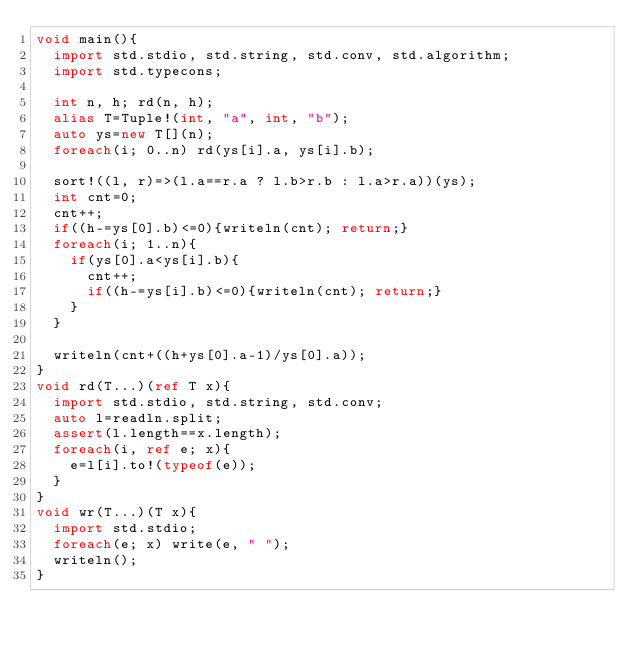Convert code to text. <code><loc_0><loc_0><loc_500><loc_500><_D_>void main(){
  import std.stdio, std.string, std.conv, std.algorithm;
  import std.typecons;
  
  int n, h; rd(n, h);
  alias T=Tuple!(int, "a", int, "b");
  auto ys=new T[](n);
  foreach(i; 0..n) rd(ys[i].a, ys[i].b);

  sort!((l, r)=>(l.a==r.a ? l.b>r.b : l.a>r.a))(ys);
  int cnt=0;
  cnt++;
  if((h-=ys[0].b)<=0){writeln(cnt); return;}
  foreach(i; 1..n){
    if(ys[0].a<ys[i].b){
      cnt++;
      if((h-=ys[i].b)<=0){writeln(cnt); return;}
    }
  }

  writeln(cnt+((h+ys[0].a-1)/ys[0].a));
}
void rd(T...)(ref T x){
  import std.stdio, std.string, std.conv;
  auto l=readln.split;
  assert(l.length==x.length);
  foreach(i, ref e; x){
    e=l[i].to!(typeof(e));
  }
}
void wr(T...)(T x){
  import std.stdio;
  foreach(e; x) write(e, " ");
  writeln();
}</code> 